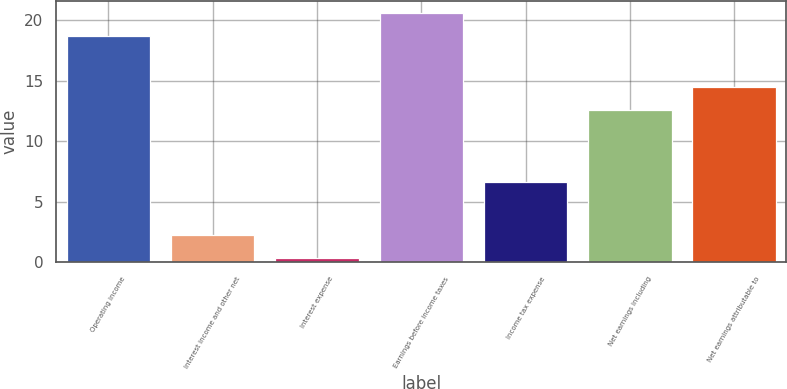Convert chart to OTSL. <chart><loc_0><loc_0><loc_500><loc_500><bar_chart><fcel>Operating income<fcel>Interest income and other net<fcel>Interest expense<fcel>Earnings before income taxes<fcel>Income tax expense<fcel>Net earnings including<fcel>Net earnings attributable to<nl><fcel>18.7<fcel>2.28<fcel>0.4<fcel>20.58<fcel>6.6<fcel>12.6<fcel>14.48<nl></chart> 